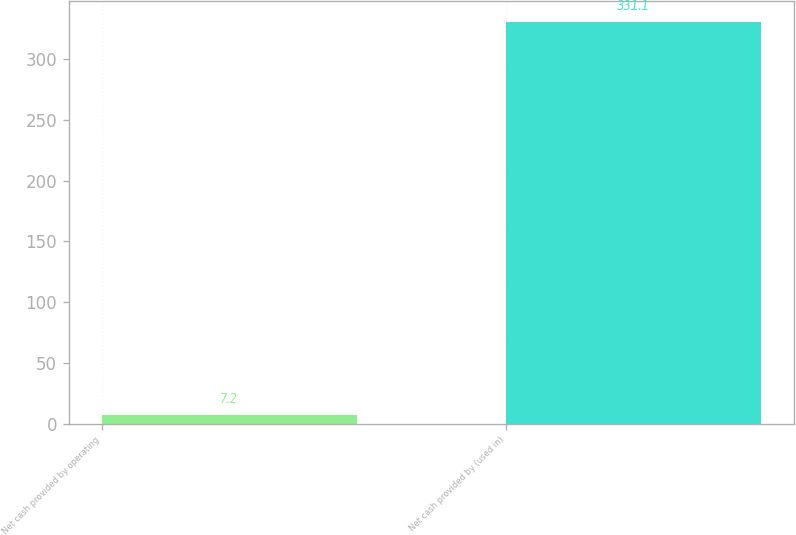<chart> <loc_0><loc_0><loc_500><loc_500><bar_chart><fcel>Net cash provided by operating<fcel>Net cash provided by (used in)<nl><fcel>7.2<fcel>331.1<nl></chart> 